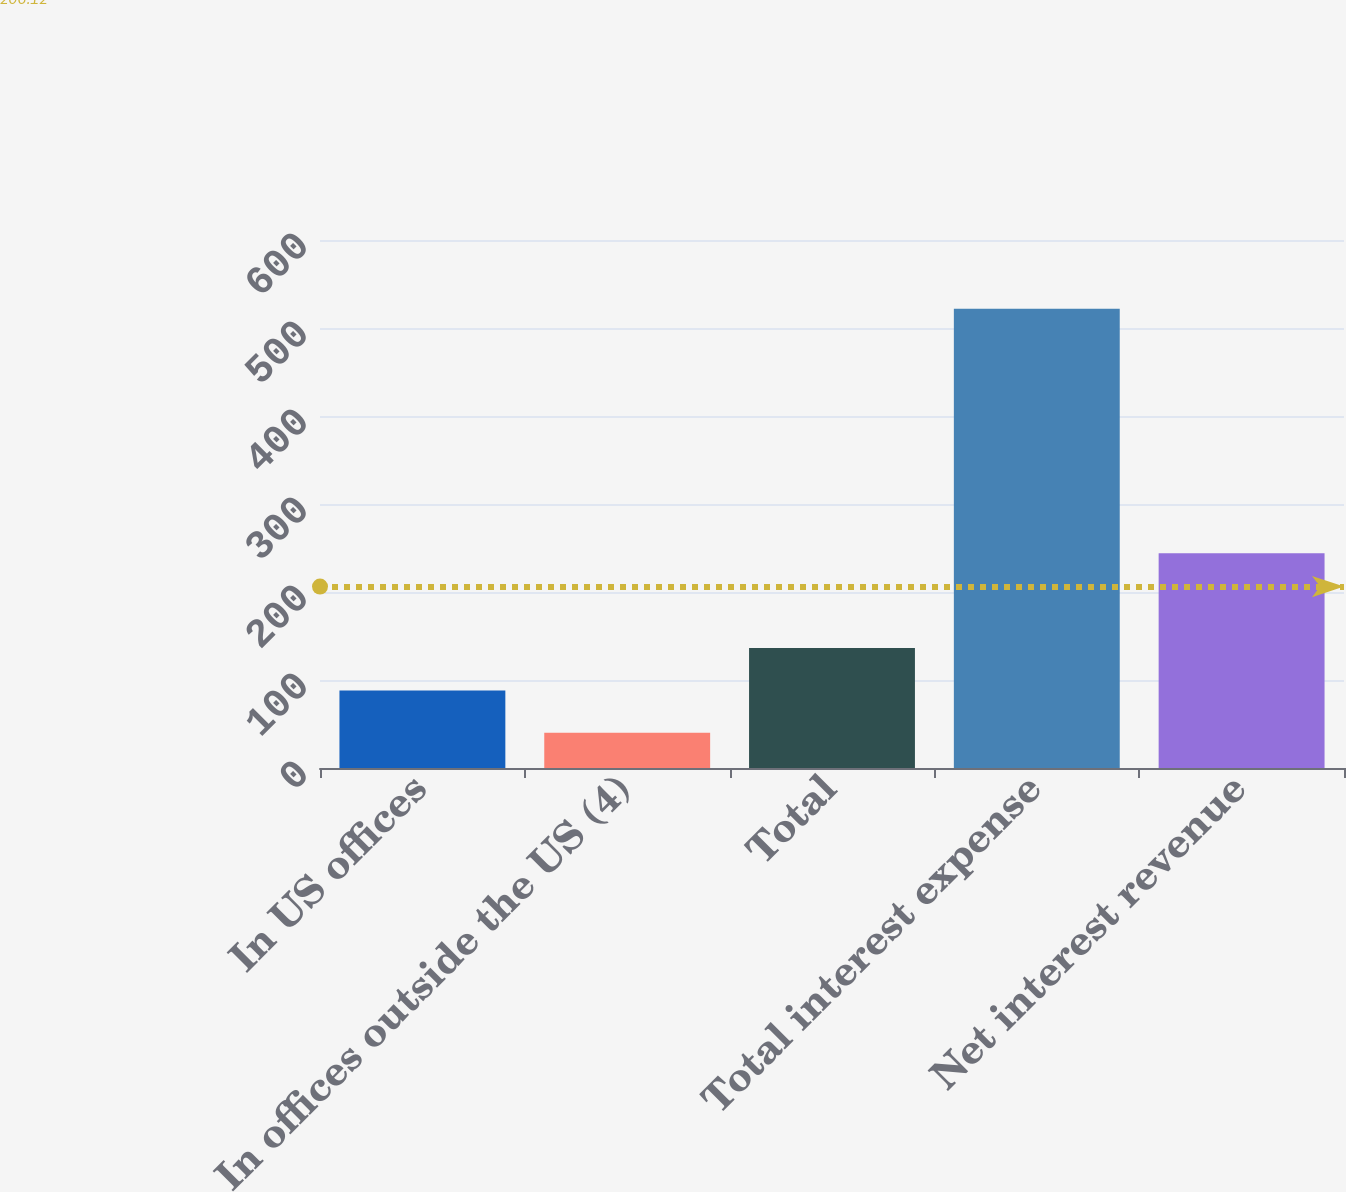Convert chart to OTSL. <chart><loc_0><loc_0><loc_500><loc_500><bar_chart><fcel>In US offices<fcel>In offices outside the US (4)<fcel>Total<fcel>Total interest expense<fcel>Net interest revenue<nl><fcel>88.2<fcel>40<fcel>136.4<fcel>522<fcel>244<nl></chart> 